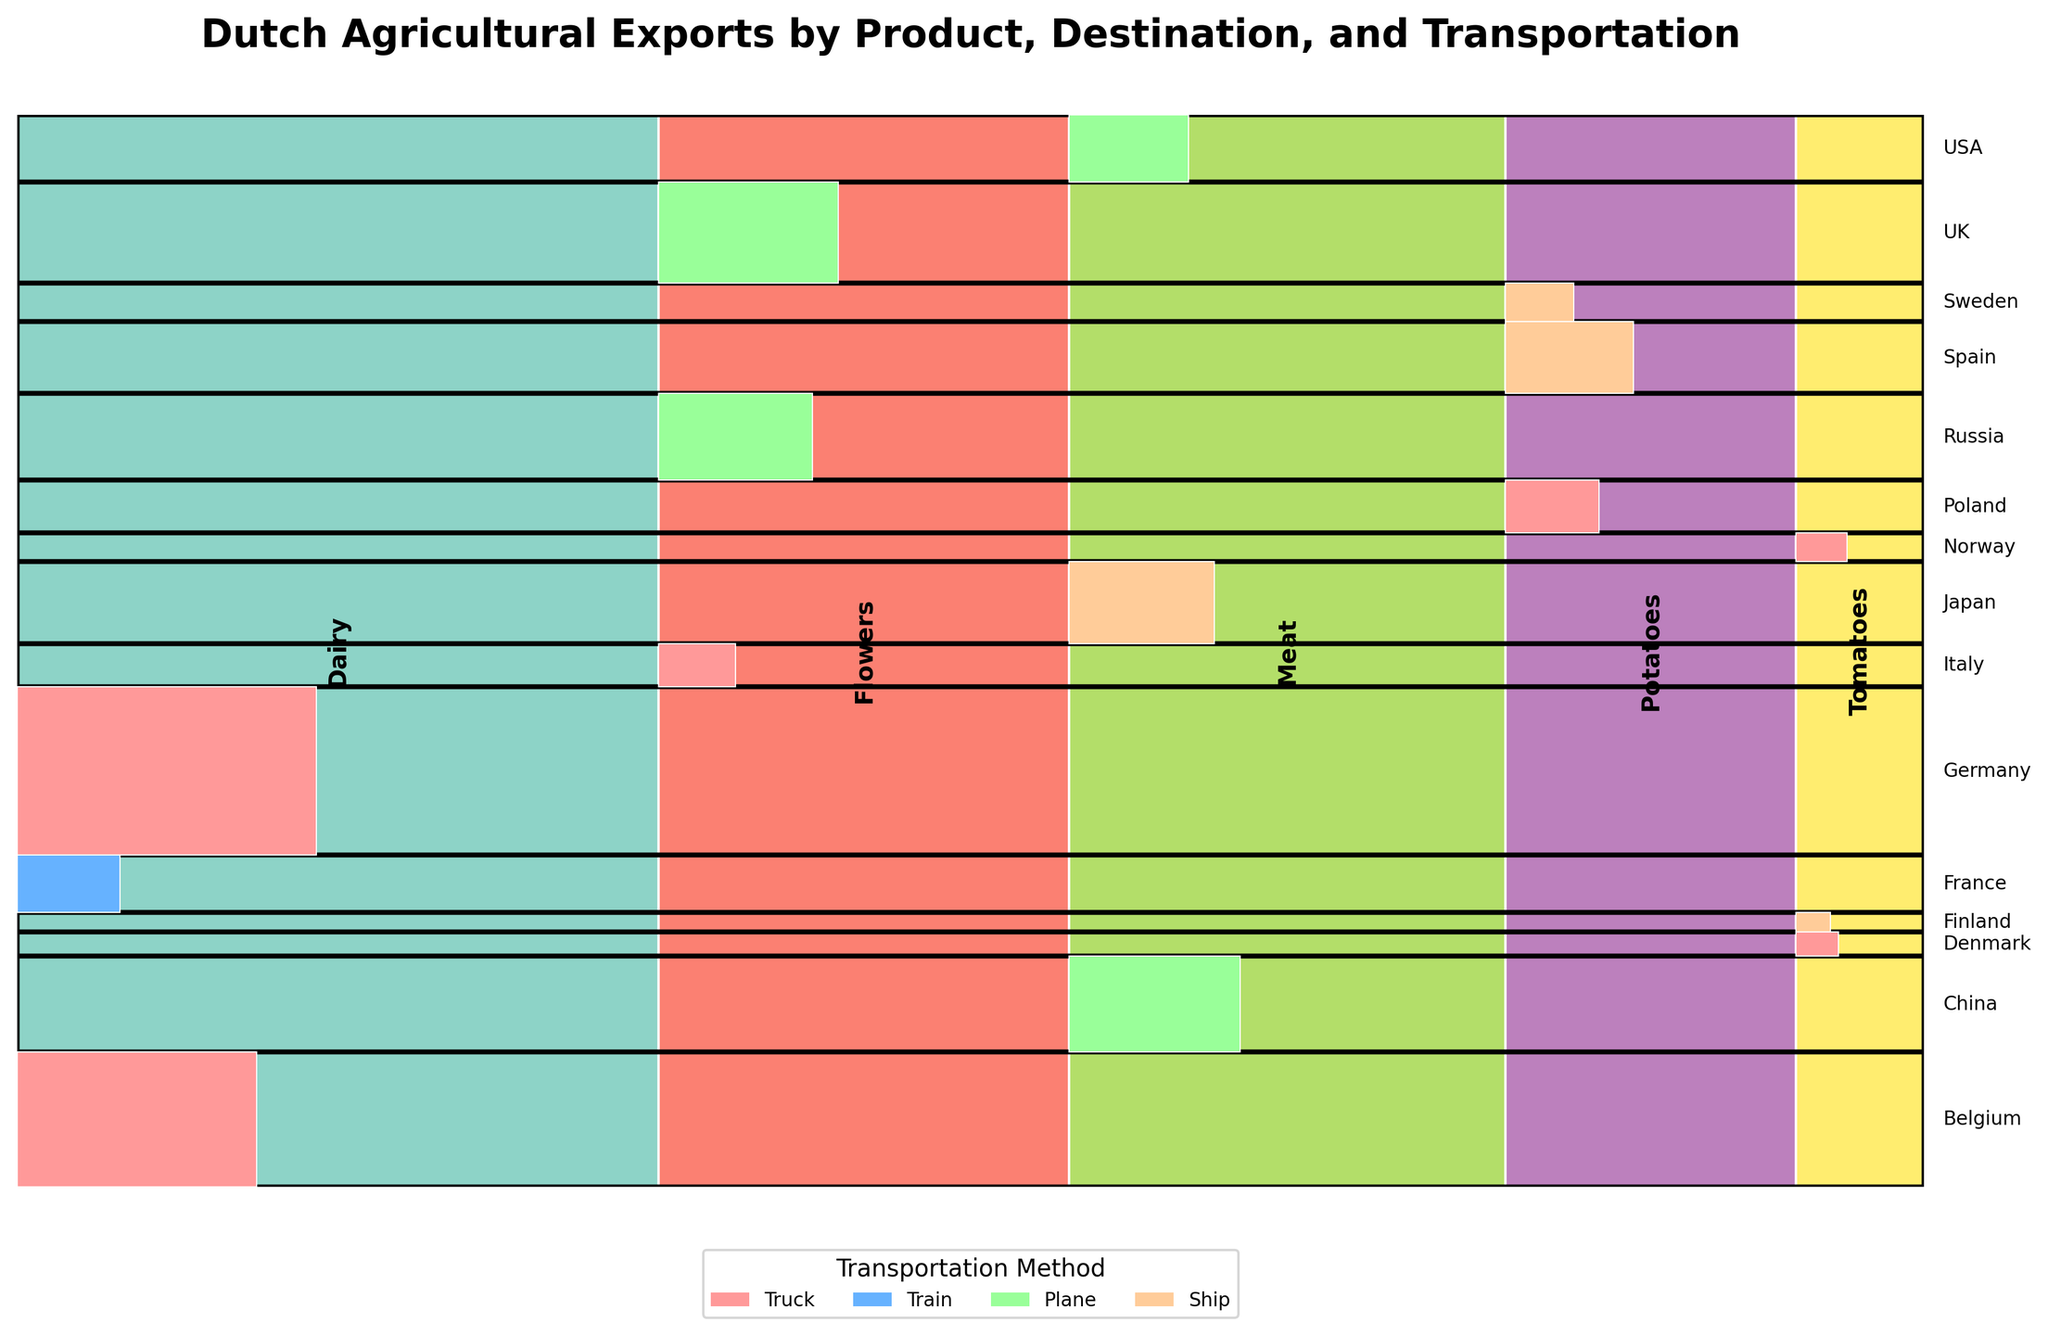What is the title of the mosaic plot? Start by looking at the top of the figure. The title is usually prominently displayed.
Answer: Dutch Agricultural Exports by Product, Destination, and Transportation Which product has the widest section in the mosaic plot? Observe the width of each product section at the bottom layer of the plot. The width represents the total value of exports for that product category.
Answer: Dairy How many transportation methods are represented in the mosaic plot? Identify the distinct colors in the legend section labeled "Transportation Method."
Answer: Four Which destination has the tallest section in the plot? Look at the height of each destination section on the right side of the plot. The height represents the total value of exports to that destination.
Answer: Germany What is the dominant transportation method for exporting flowers? Analyze the sections within the flowers category. Observe the color that occupies the largest area.
Answer: Plane How does the export value of potatoes to Spain compare to Sweden? Find the sections representing potatoes and look within those sections to compare the values to Spain (represented vertically) and Sweden. Spain has a larger height.
Answer: Spain has a higher export value Is the distribution of transportation methods uniform across all product categories? Look at the color distribution (representing transportation methods) within each product category. See if any method disproportionately dominates or if they are evenly spread.
Answer: No, it is not uniform Which product category uses the ship most for transportation? Identify the sections colored as "Ship" and see which product category contains the largest area with this color.
Answer: Potatoes What is the total number of export destinations represented in the mosaic plot? Count the number of distinct destinations listed.
Answer: Thirteen What proportion of meat exports is transported by plane? Look at the meat category and examine the sections colored as "Plane." The proportion can be visually estimated by the area occupied by that color in the meat section.
Answer: Plane dominates meat exports 